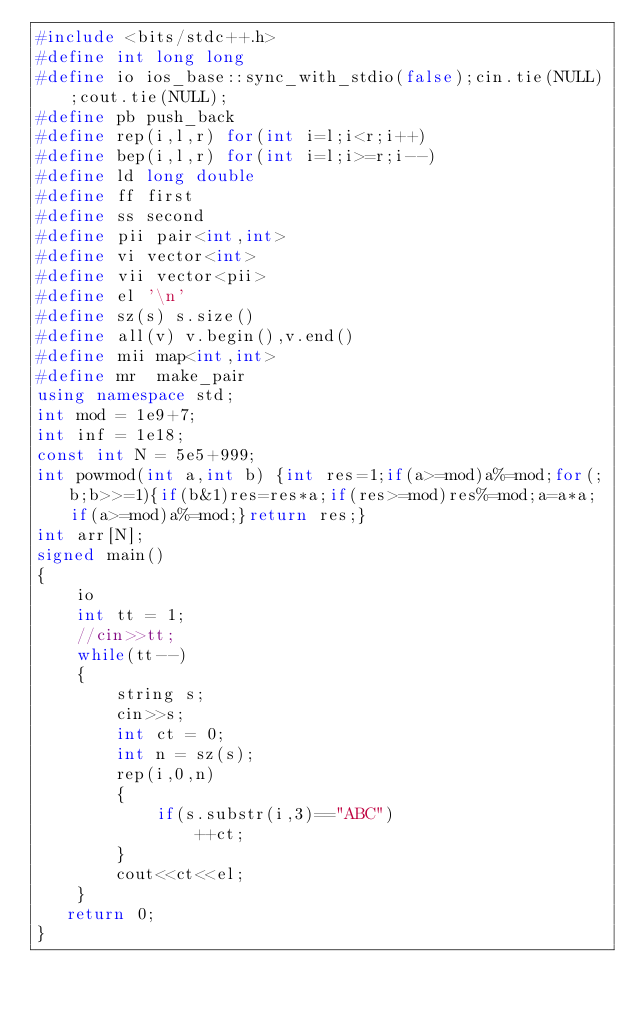<code> <loc_0><loc_0><loc_500><loc_500><_C++_>#include <bits/stdc++.h>
#define int long long
#define io ios_base::sync_with_stdio(false);cin.tie(NULL);cout.tie(NULL);
#define pb push_back
#define rep(i,l,r) for(int i=l;i<r;i++)
#define bep(i,l,r) for(int i=l;i>=r;i--)
#define ld long double
#define ff first
#define ss second
#define pii pair<int,int>
#define vi vector<int>
#define vii vector<pii>
#define el '\n'
#define sz(s) s.size()
#define all(v) v.begin(),v.end()
#define mii map<int,int>
#define mr  make_pair
using namespace std;
int mod = 1e9+7;
int inf = 1e18;
const int N = 5e5+999;
int powmod(int a,int b) {int res=1;if(a>=mod)a%=mod;for(;b;b>>=1){if(b&1)res=res*a;if(res>=mod)res%=mod;a=a*a;if(a>=mod)a%=mod;}return res;}
int arr[N];
signed main()
{
    io
    int tt = 1;
    //cin>>tt;
    while(tt--)
    {
        string s;
        cin>>s;
        int ct = 0;
        int n = sz(s);
        rep(i,0,n)
        {
            if(s.substr(i,3)=="ABC")
                ++ct;
        }
        cout<<ct<<el;
    }
   return 0;
}
</code> 